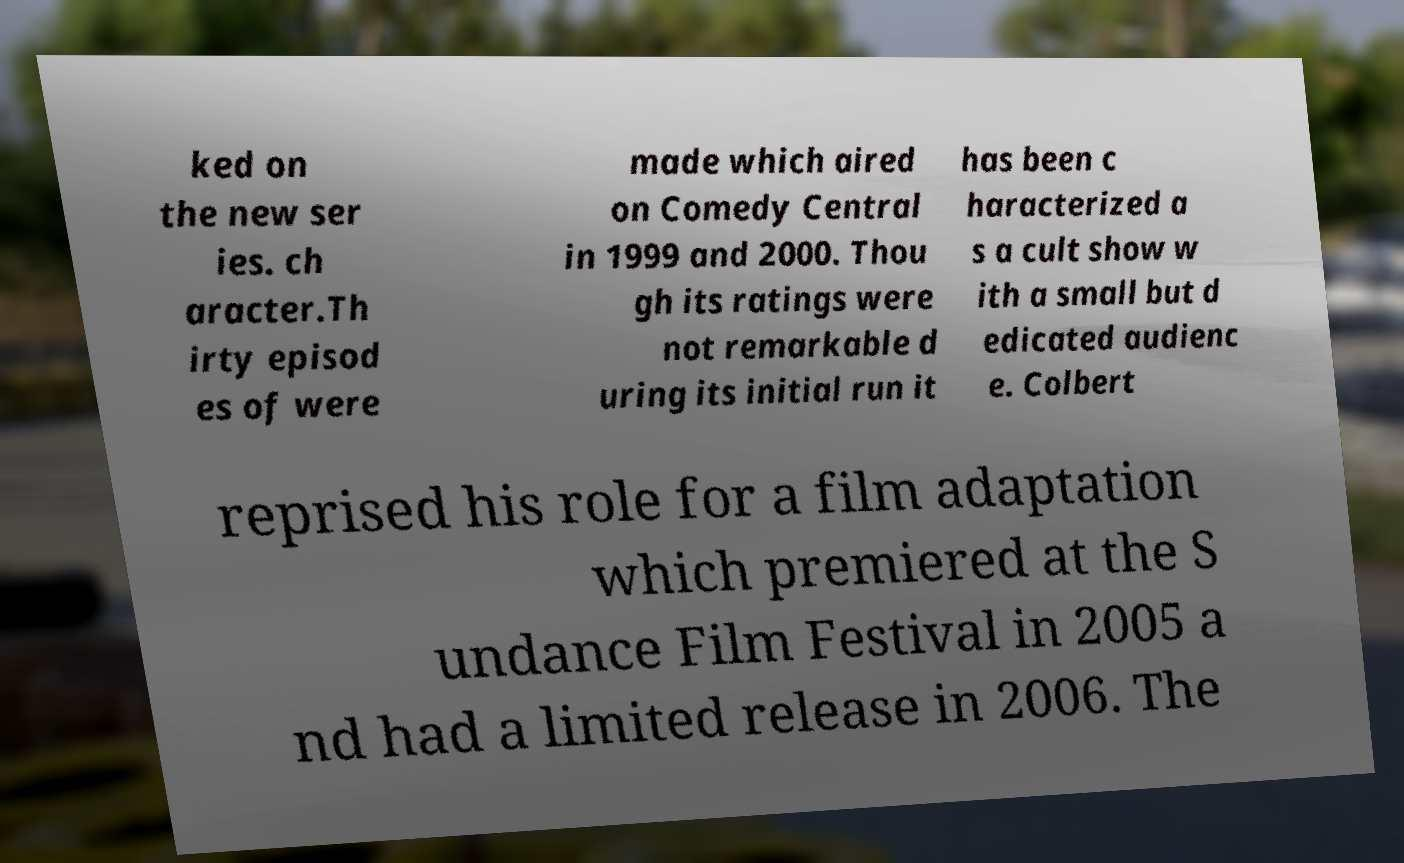There's text embedded in this image that I need extracted. Can you transcribe it verbatim? ked on the new ser ies. ch aracter.Th irty episod es of were made which aired on Comedy Central in 1999 and 2000. Thou gh its ratings were not remarkable d uring its initial run it has been c haracterized a s a cult show w ith a small but d edicated audienc e. Colbert reprised his role for a film adaptation which premiered at the S undance Film Festival in 2005 a nd had a limited release in 2006. The 